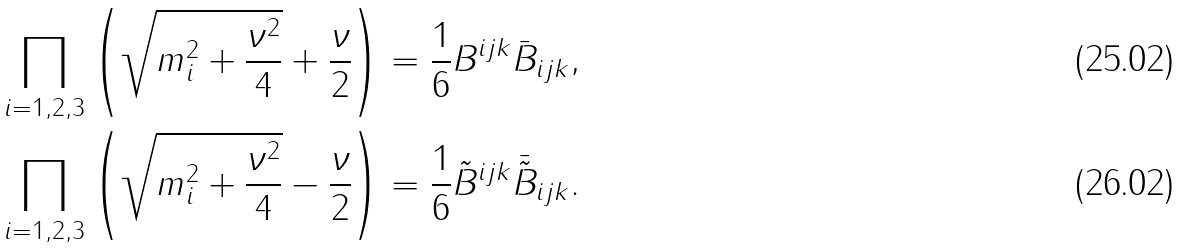<formula> <loc_0><loc_0><loc_500><loc_500>\prod _ { i = 1 , 2 , 3 } \left ( \sqrt { m _ { i } ^ { 2 } + \frac { \nu ^ { 2 } } 4 } + \frac { \nu } { 2 } \right ) & = \frac { 1 } { 6 } B ^ { i j k } \bar { B } _ { i j k } , \\ \prod _ { i = 1 , 2 , 3 } \left ( \sqrt { m _ { i } ^ { 2 } + \frac { \nu ^ { 2 } } 4 } - \frac { \nu } { 2 } \right ) & = \frac { 1 } { 6 } \tilde { B } ^ { i j k } \bar { \tilde { B } } _ { i j k } .</formula> 